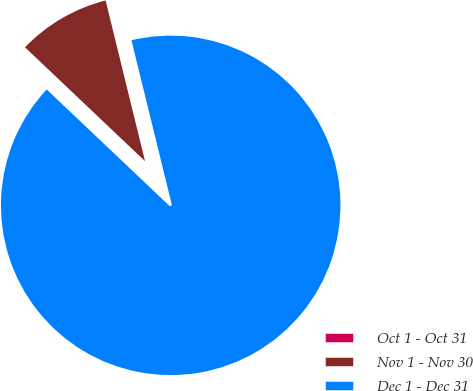Convert chart. <chart><loc_0><loc_0><loc_500><loc_500><pie_chart><fcel>Oct 1 - Oct 31<fcel>Nov 1 - Nov 30<fcel>Dec 1 - Dec 31<nl><fcel>0.0%<fcel>9.09%<fcel>90.91%<nl></chart> 